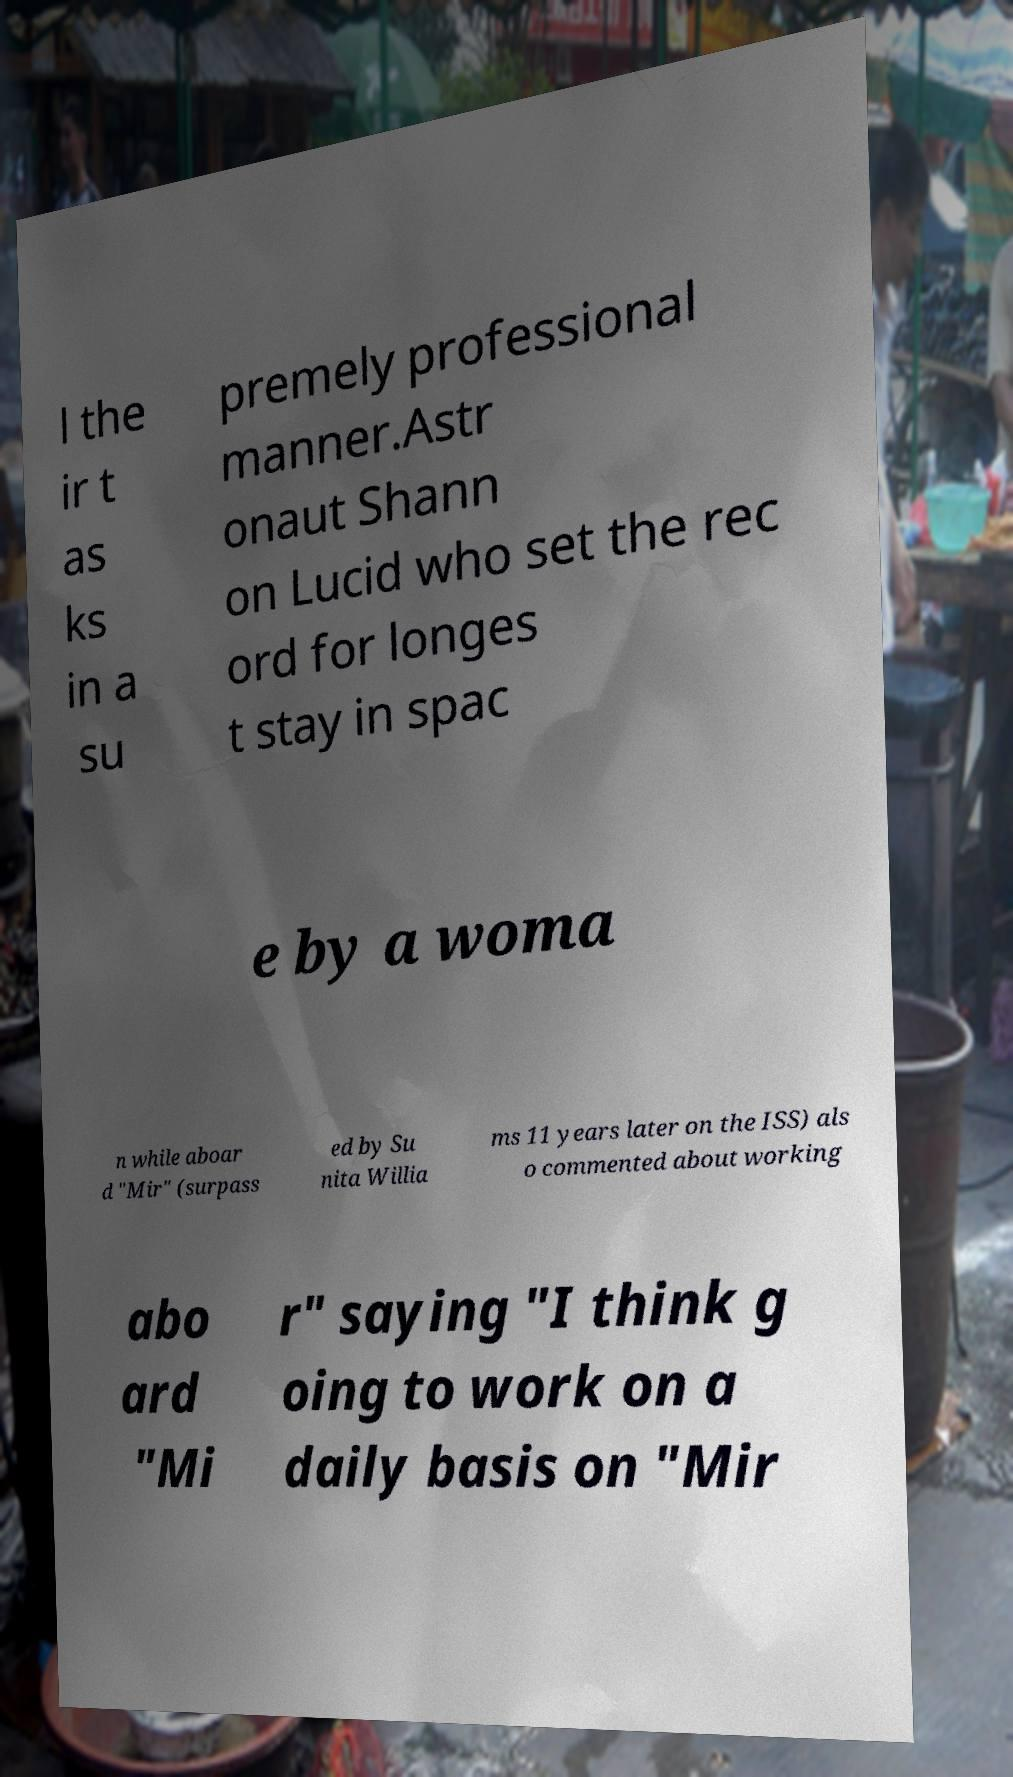Please read and relay the text visible in this image. What does it say? l the ir t as ks in a su premely professional manner.Astr onaut Shann on Lucid who set the rec ord for longes t stay in spac e by a woma n while aboar d "Mir" (surpass ed by Su nita Willia ms 11 years later on the ISS) als o commented about working abo ard "Mi r" saying "I think g oing to work on a daily basis on "Mir 